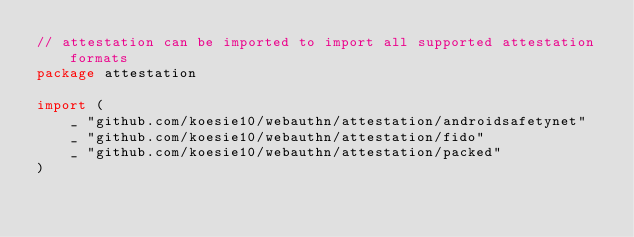<code> <loc_0><loc_0><loc_500><loc_500><_Go_>// attestation can be imported to import all supported attestation formats
package attestation

import (
	_ "github.com/koesie10/webauthn/attestation/androidsafetynet"
	_ "github.com/koesie10/webauthn/attestation/fido"
	_ "github.com/koesie10/webauthn/attestation/packed"
)
</code> 